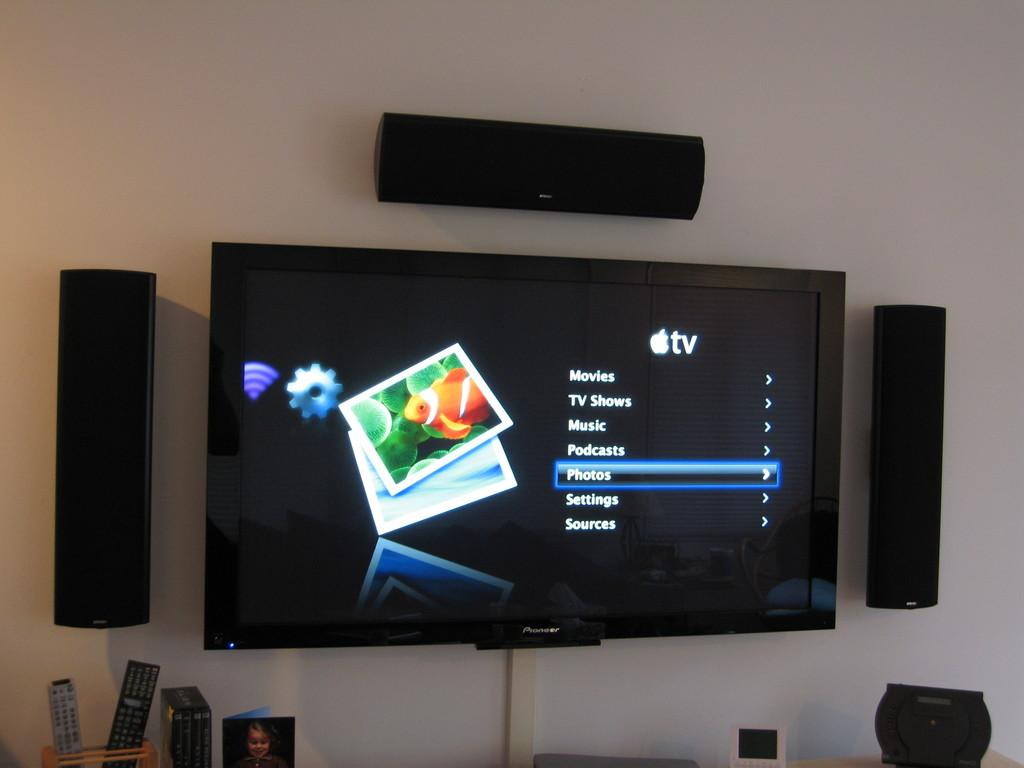Provide a one-sentence caption for the provided image. A television screen with the list item Photos selected. 